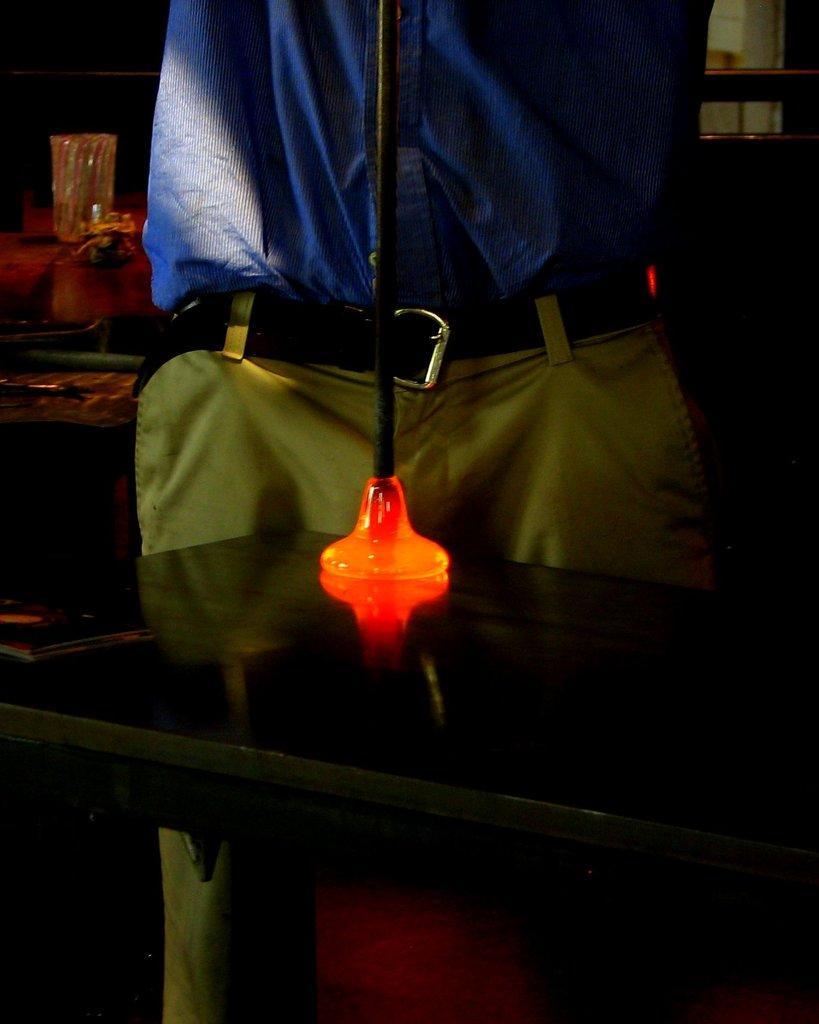Please provide a concise description of this image. In this picture there is a man who is wearing shirt, belt, trouser and holding a rod which is attached to this heated glass. Behind him I can see the wine glass which is kept on the table. 